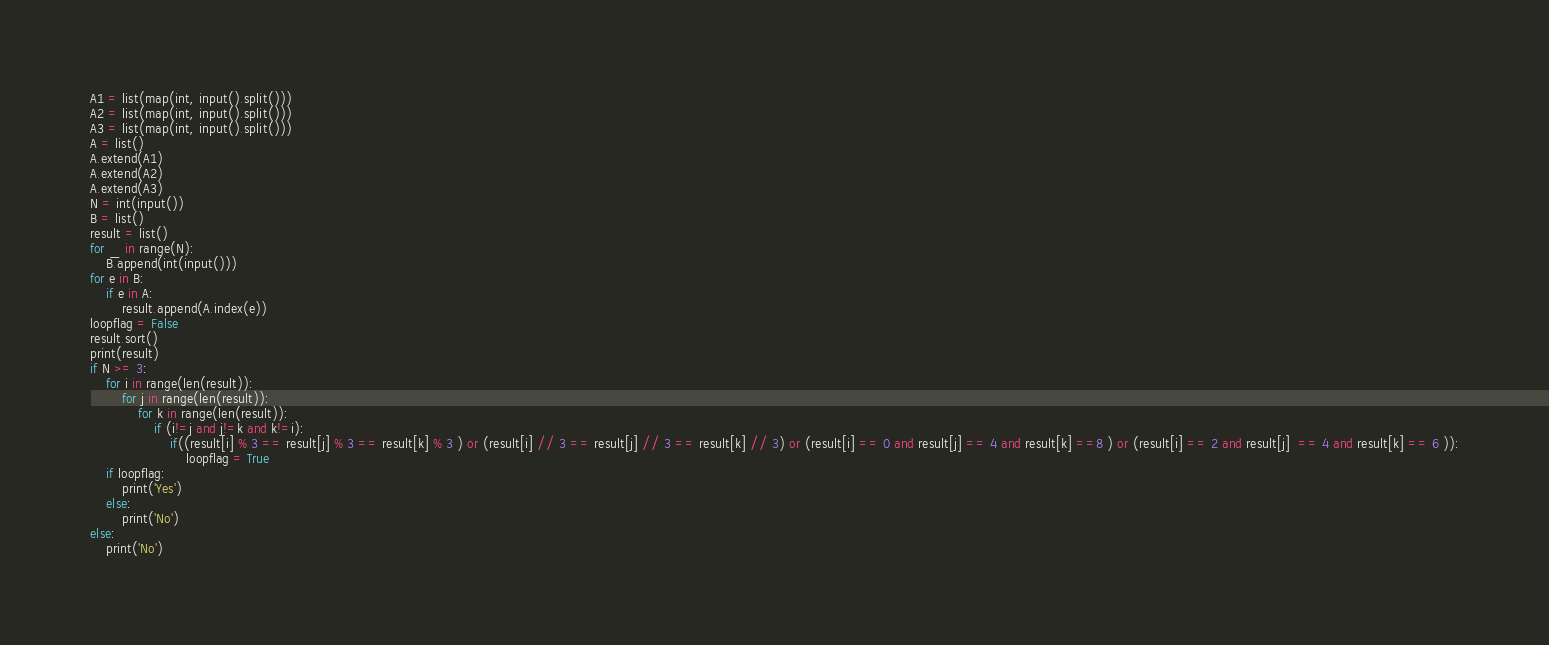<code> <loc_0><loc_0><loc_500><loc_500><_Python_>A1 = list(map(int, input().split()))
A2 = list(map(int, input().split()))
A3 = list(map(int, input().split()))
A = list()
A.extend(A1)
A.extend(A2)
A.extend(A3)
N = int(input())
B = list()
result = list()
for _ in range(N):
    B.append(int(input()))
for e in B:
    if e in A:
        result.append(A.index(e))
loopflag = False
result.sort()
print(result)
if N >= 3:
    for i in range(len(result)):
        for j in range(len(result)):
            for k in range(len(result)):
                if (i!=j and j!=k and k!=i):
                    if((result[i] % 3 == result[j] % 3 == result[k] % 3 ) or (result[i] // 3 == result[j] // 3 == result[k] // 3) or (result[i] == 0 and result[j] == 4 and result[k] ==8 ) or (result[i] == 2 and result[j]  == 4 and result[k] == 6 )):
                        loopflag = True
    if loopflag:
        print('Yes')
    else:
        print('No')
else:
    print('No')</code> 